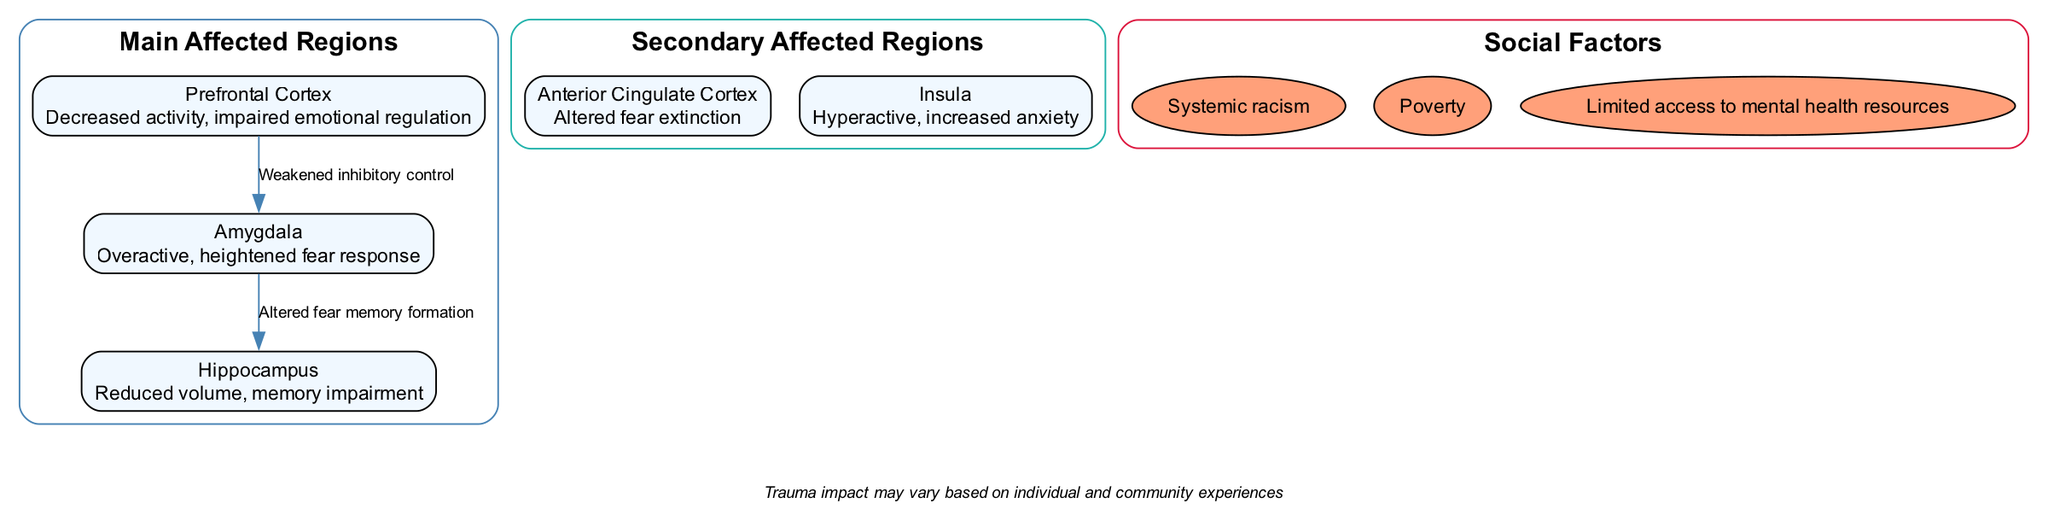What brain region is overactive in response to fear? The diagram indicates that the Amygdala is overactive, leading to a heightened fear response. This information can be found in the section describing the main regions.
Answer: Amygdala What condition is associated with the reduced volume of the Hippocampus? The diagram specifies that the Hippocampus has reduced volume, which correlates with memory impairment. This association is described in the section of main regions affected by trauma.
Answer: Memory impairment How many main affected regions are listed in the diagram? The diagram displays three main regions: Amygdala, Hippocampus, and Prefrontal Cortex. A simple count of these regions reveals the total.
Answer: 3 What is the label of the connection from the Prefrontal Cortex to the Amygdala? The diagram labels the connection from the Prefrontal Cortex to the Amygdala as "Weakened inhibitory control." This information is directly shown in the connections section.
Answer: Weakened inhibitory control Which secondary region is described as hyperactive? The Insula is described as hyperactive in the diagram, leading to increased anxiety. This detail can be found in the section about secondary affected regions.
Answer: Insula What social factor is listed that contributes to the trauma impact? The diagram lists "Systemic racism" as one of the social factors affecting trauma impact in marginalized communities. This information is found in the social factors section.
Answer: Systemic racism What relationship does the diagram indicate between the Amygdala and the Hippocampus? The diagram indicates that there is an altered memory formation of fear that connects the Amygdala and Hippocampus, illustrating how they interact within the context of trauma and PTSD.
Answer: Altered fear memory formation How does the decreased activity in the Prefrontal Cortex affect emotional regulation? The diagram indicates that decreased activity in the Prefrontal Cortex leads to impaired emotional regulation, establishing the significance of this brain area's role in managing emotions.
Answer: Impaired emotional regulation What is notable about the note provided in the diagram? The note emphasizes that the trauma impact may vary based on individual and community experiences, highlighting the complexities and individual differences in trauma responses.
Answer: Trauma impact may vary based on individual and community experiences 